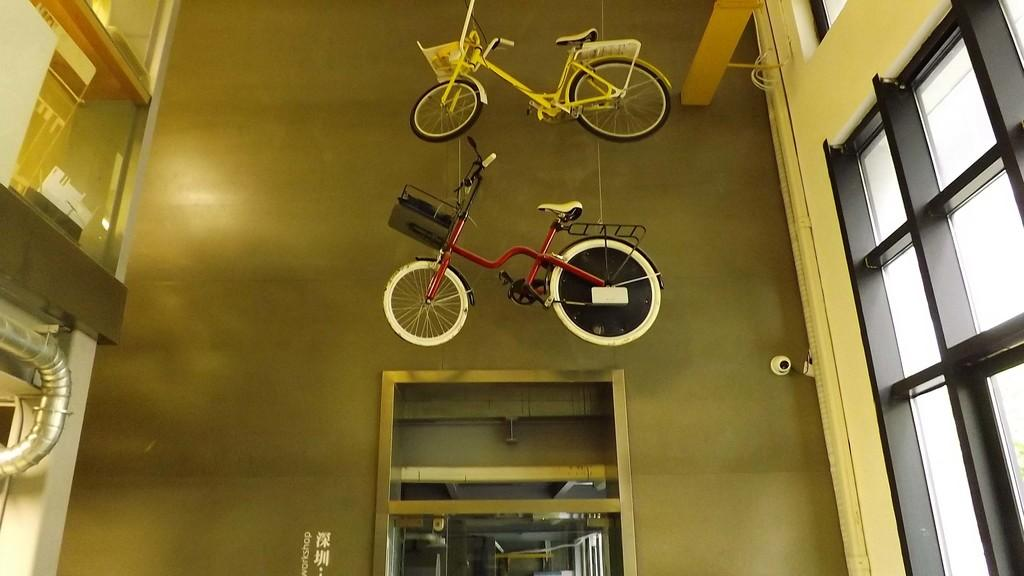Where was the image taken? The image was taken inside a building. What can be seen hanging on the top of the image? Two bicycles are hanged on the top. What is present on the right side of the image? There is a glass window on the right side. What is the purpose of this area in the building? This is an entrance. What material is the tube on the left side made of? The tube on the left side is made of metal. What type of event is taking place in the image? There is no event taking place in the image; it is a static scene inside a building. Can you see any mountains in the image? No, there are no mountains visible in the image. What kind of linen is draped over the bicycles? There is no linen present in the image; the bicycles are hanging without any fabric covering them. 